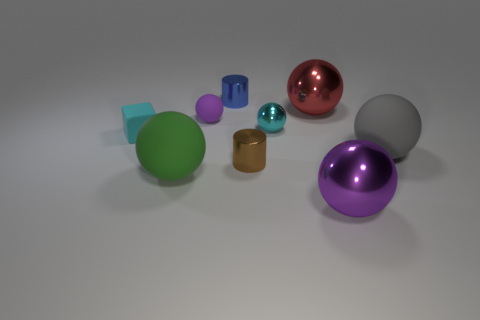Add 1 green rubber balls. How many objects exist? 10 Subtract all big green rubber spheres. How many spheres are left? 5 Subtract all brown cylinders. How many green spheres are left? 1 Subtract all brown rubber cylinders. Subtract all gray balls. How many objects are left? 8 Add 7 large red metallic objects. How many large red metallic objects are left? 8 Add 4 purple rubber spheres. How many purple rubber spheres exist? 5 Subtract all cyan balls. How many balls are left? 5 Subtract 2 purple spheres. How many objects are left? 7 Subtract all spheres. How many objects are left? 3 Subtract 1 cubes. How many cubes are left? 0 